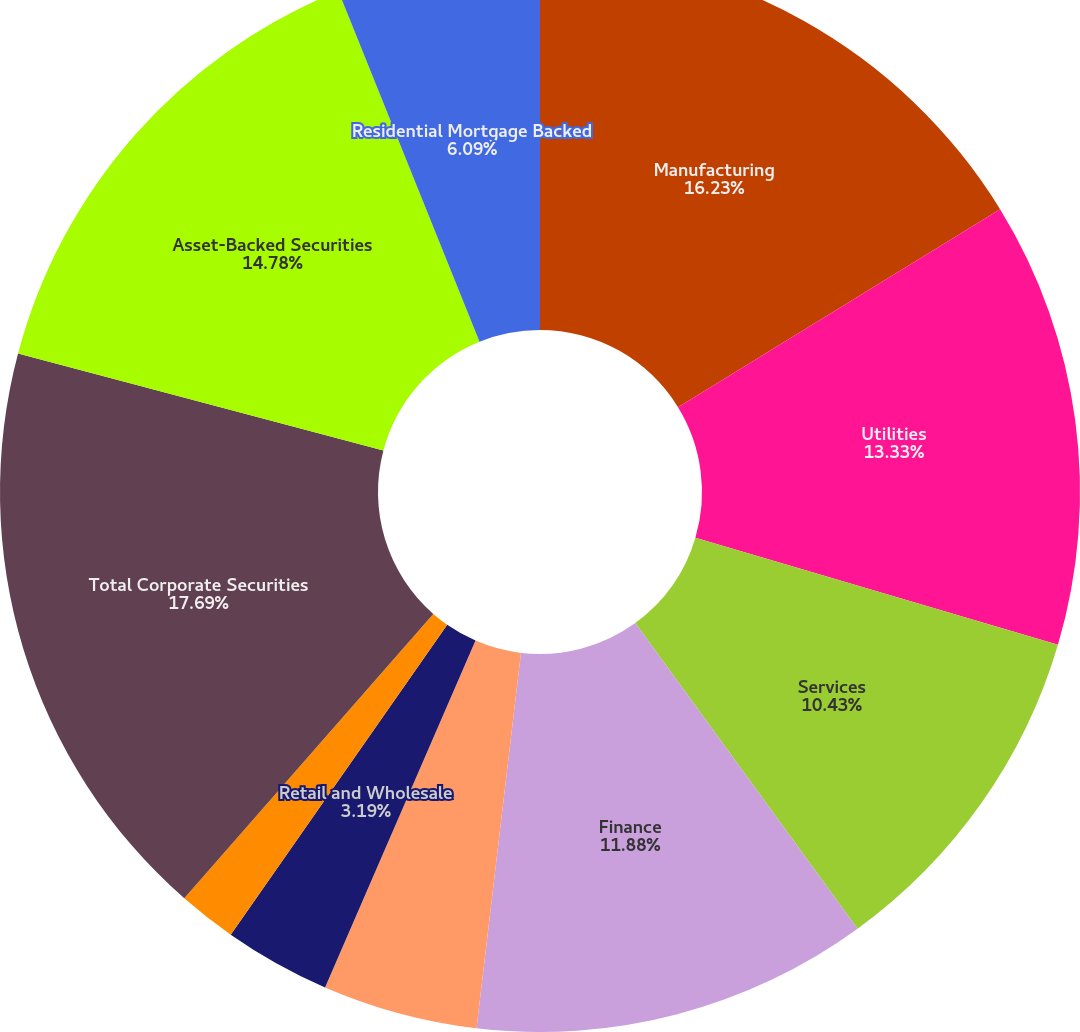Convert chart. <chart><loc_0><loc_0><loc_500><loc_500><pie_chart><fcel>Manufacturing<fcel>Utilities<fcel>Services<fcel>Finance<fcel>Energy<fcel>Retail and Wholesale<fcel>Transportation<fcel>Total Corporate Securities<fcel>Asset-Backed Securities<fcel>Residential Mortgage Backed<nl><fcel>16.23%<fcel>13.33%<fcel>10.43%<fcel>11.88%<fcel>4.64%<fcel>3.19%<fcel>1.74%<fcel>17.68%<fcel>14.78%<fcel>6.09%<nl></chart> 